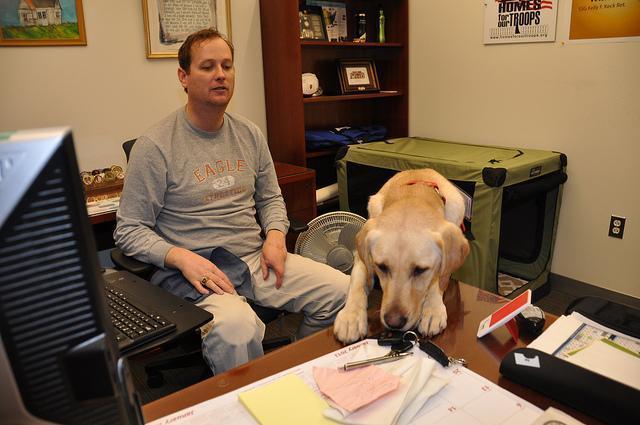Verify the accuracy of this image caption: "The tv is at the left side of the person.".
Answer yes or no. Yes. 